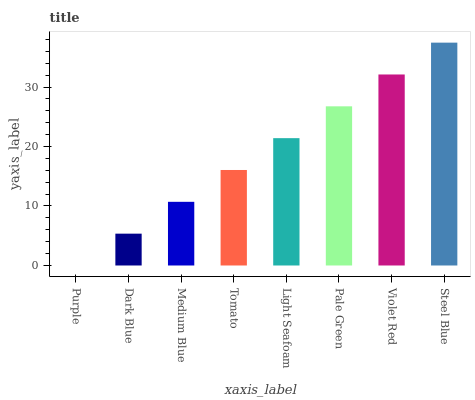Is Purple the minimum?
Answer yes or no. Yes. Is Steel Blue the maximum?
Answer yes or no. Yes. Is Dark Blue the minimum?
Answer yes or no. No. Is Dark Blue the maximum?
Answer yes or no. No. Is Dark Blue greater than Purple?
Answer yes or no. Yes. Is Purple less than Dark Blue?
Answer yes or no. Yes. Is Purple greater than Dark Blue?
Answer yes or no. No. Is Dark Blue less than Purple?
Answer yes or no. No. Is Light Seafoam the high median?
Answer yes or no. Yes. Is Tomato the low median?
Answer yes or no. Yes. Is Dark Blue the high median?
Answer yes or no. No. Is Light Seafoam the low median?
Answer yes or no. No. 